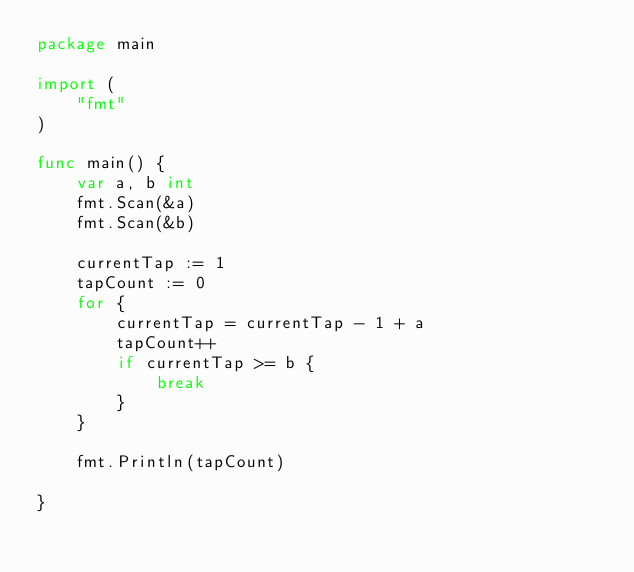Convert code to text. <code><loc_0><loc_0><loc_500><loc_500><_Go_>package main

import (
	"fmt"
)

func main() {
	var a, b int
	fmt.Scan(&a)
	fmt.Scan(&b)

	currentTap := 1
	tapCount := 0
	for {
		currentTap = currentTap - 1 + a
		tapCount++
		if currentTap >= b {
			break
		}
	}

	fmt.Println(tapCount)

}
</code> 